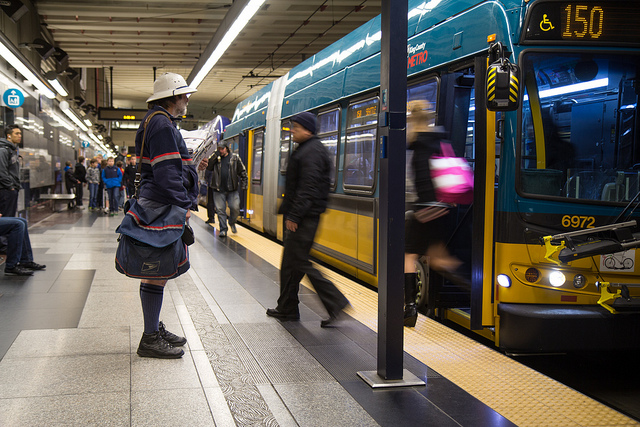Please transcribe the text information in this image. 150 6972 